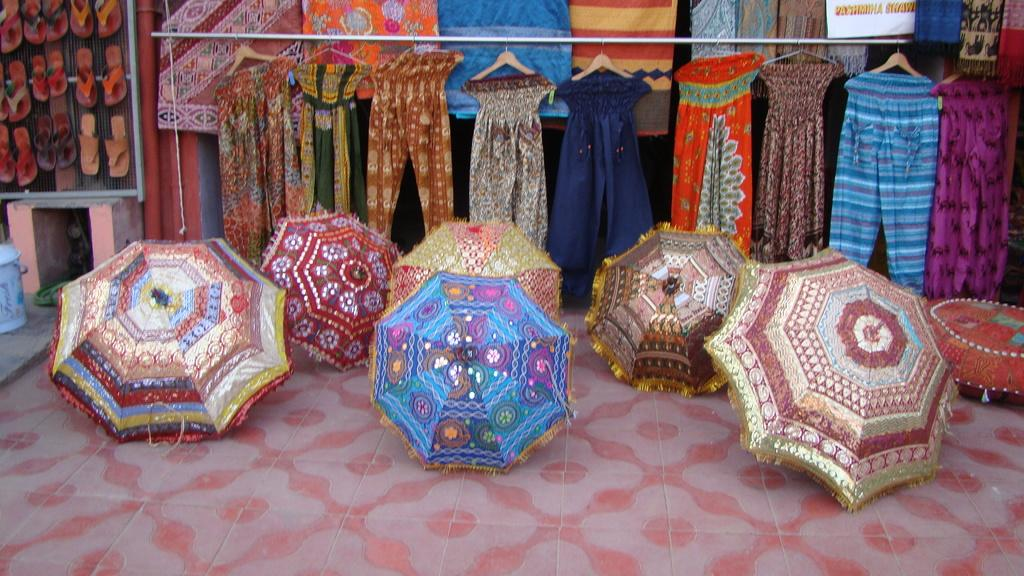What objects are on the floor in the center of the image? There are umbrellas on the floor in the center of the image. What can be seen in the background of the image? There are clothes and footwear in the background of the image. Where is the blue color bin located in the image? The blue color bin is to the left side of the image. Reasoning: Let'g: Let's think step by step in order to produce the conversation. We start by identifying the main objects on the floor, which are the umbrellas. Then, we expand the conversation to include other items that are also visible in the background, such as clothes and footwear. Finally, we mention the location of the blue color bin, which is on the left side of the image. Absurd Question/Answer: What type of store is depicted in the image? There is no store present in the image; it features umbrellas on the floor, clothes, footwear, and a blue color bin. How does the image evoke feelings of disgust or pleasure? The image does not evoke feelings of disgust or pleasure, as it is a neutral representation of objects and items. 